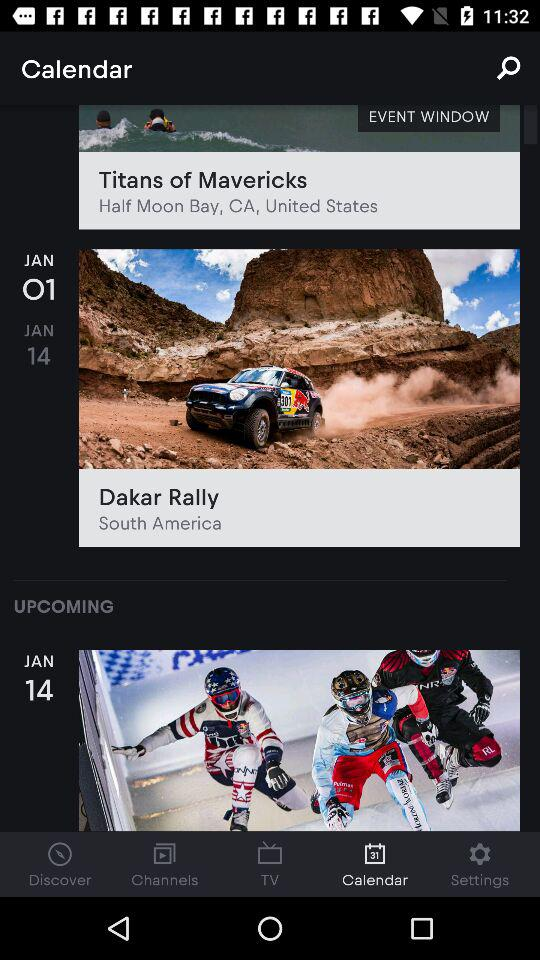What is the name of the event that is taking place in the United States?
Answer the question using a single word or phrase. Titans of Mavericks 